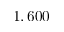<formula> <loc_0><loc_0><loc_500><loc_500>1 , 6 0 0</formula> 